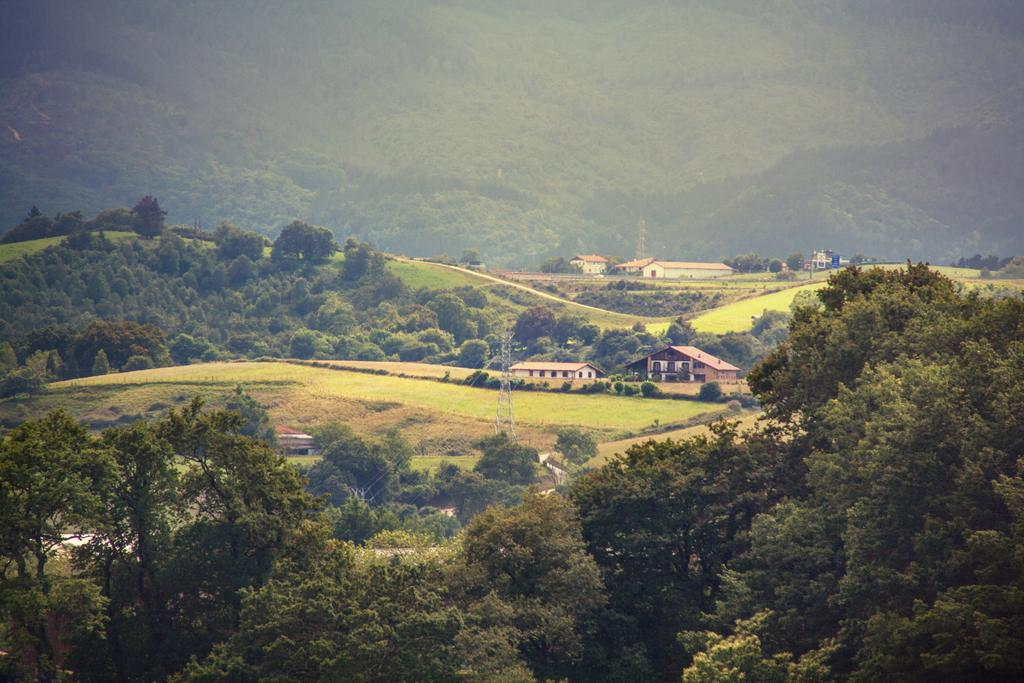What type of natural elements can be seen in the image? There are trees in the image. What type of man-made structures are present in the image? There are buildings in the image. Can you describe the setting of the image based on the presence of trees and buildings? The image appears to depict a scene with both natural and urban elements, possibly a city or town with trees and buildings. Where is the jewel located in the image? There is no jewel present in the image. Can you see any animals in the image? The provided facts do not mention any animals in the image. 